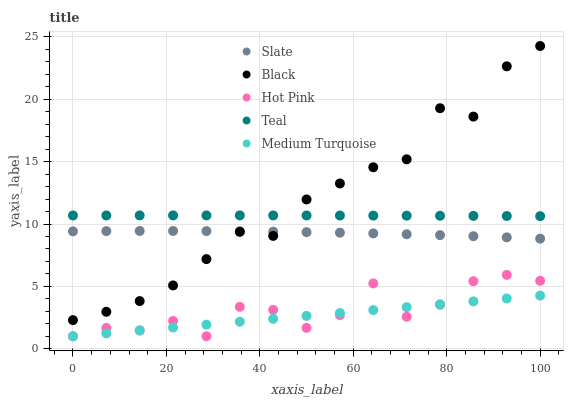Does Medium Turquoise have the minimum area under the curve?
Answer yes or no. Yes. Does Black have the maximum area under the curve?
Answer yes or no. Yes. Does Hot Pink have the minimum area under the curve?
Answer yes or no. No. Does Hot Pink have the maximum area under the curve?
Answer yes or no. No. Is Medium Turquoise the smoothest?
Answer yes or no. Yes. Is Hot Pink the roughest?
Answer yes or no. Yes. Is Black the smoothest?
Answer yes or no. No. Is Black the roughest?
Answer yes or no. No. Does Hot Pink have the lowest value?
Answer yes or no. Yes. Does Black have the lowest value?
Answer yes or no. No. Does Black have the highest value?
Answer yes or no. Yes. Does Hot Pink have the highest value?
Answer yes or no. No. Is Hot Pink less than Black?
Answer yes or no. Yes. Is Slate greater than Medium Turquoise?
Answer yes or no. Yes. Does Black intersect Slate?
Answer yes or no. Yes. Is Black less than Slate?
Answer yes or no. No. Is Black greater than Slate?
Answer yes or no. No. Does Hot Pink intersect Black?
Answer yes or no. No. 